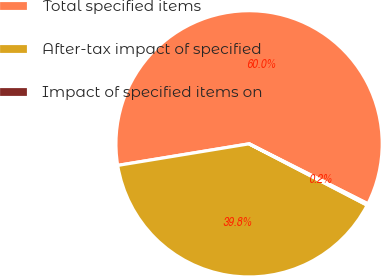<chart> <loc_0><loc_0><loc_500><loc_500><pie_chart><fcel>Total specified items<fcel>After-tax impact of specified<fcel>Impact of specified items on<nl><fcel>60.03%<fcel>39.78%<fcel>0.19%<nl></chart> 